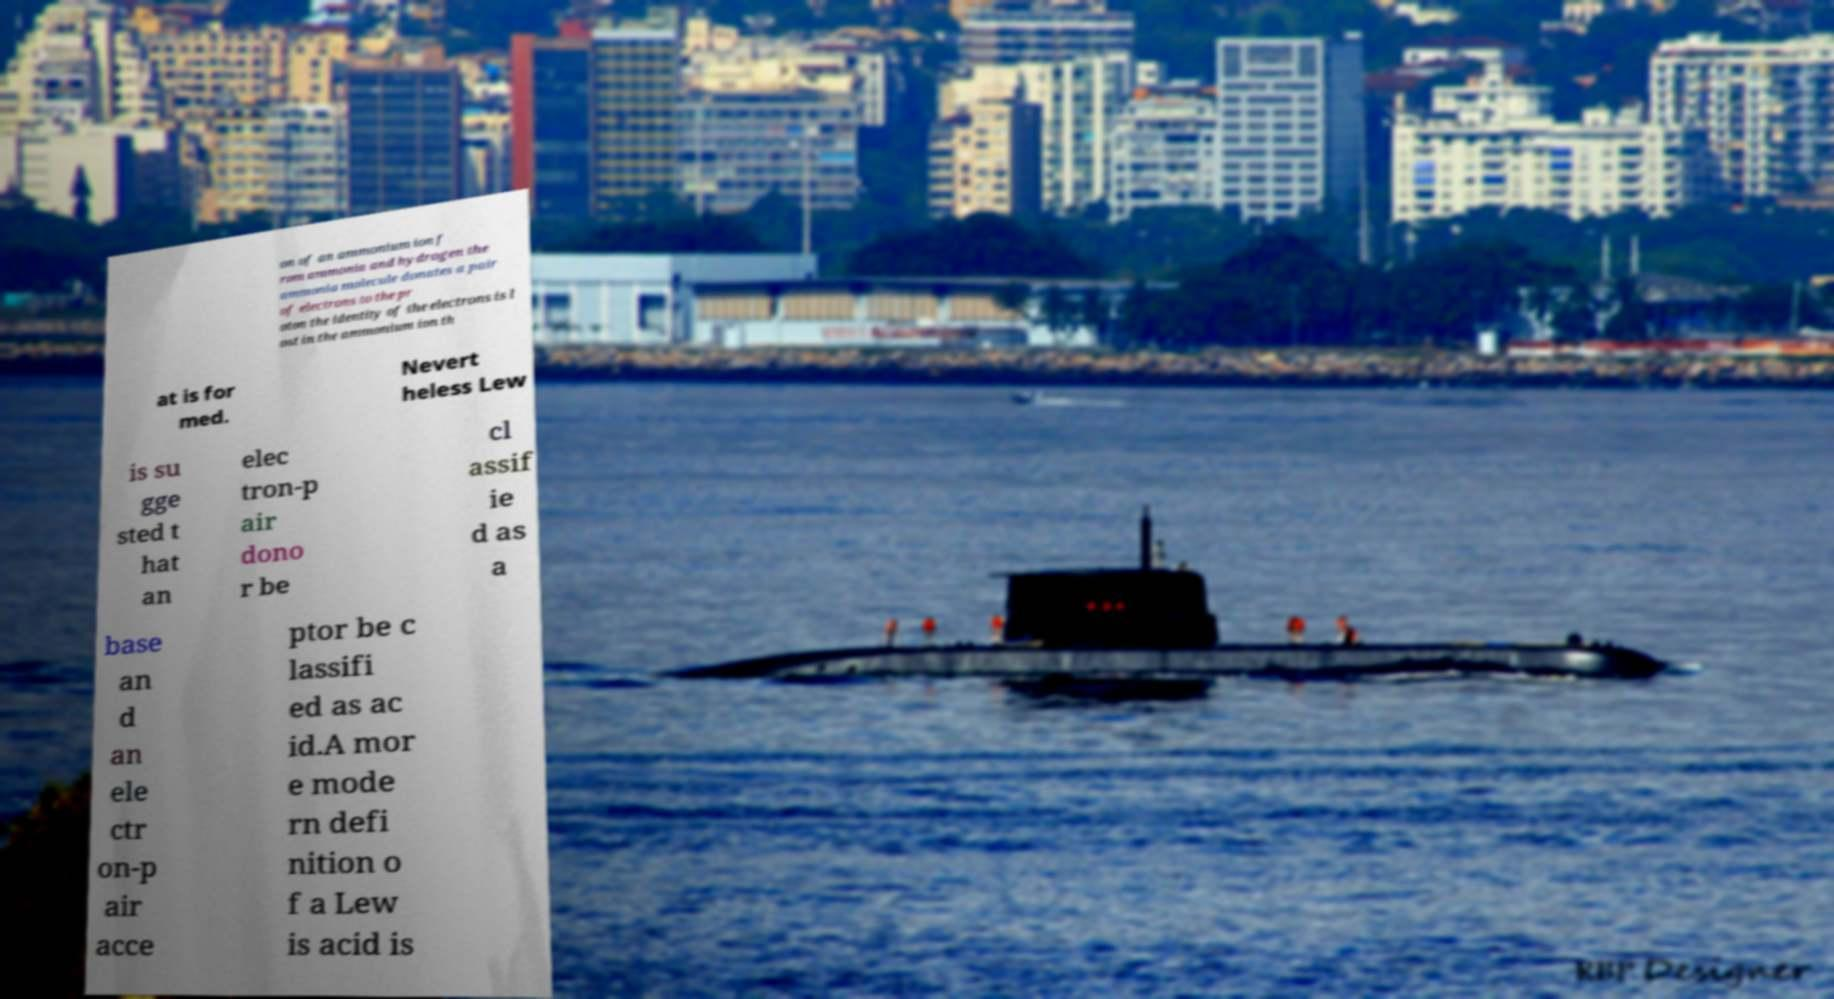Please read and relay the text visible in this image. What does it say? on of an ammonium ion f rom ammonia and hydrogen the ammonia molecule donates a pair of electrons to the pr oton the identity of the electrons is l ost in the ammonium ion th at is for med. Nevert heless Lew is su gge sted t hat an elec tron-p air dono r be cl assif ie d as a base an d an ele ctr on-p air acce ptor be c lassifi ed as ac id.A mor e mode rn defi nition o f a Lew is acid is 